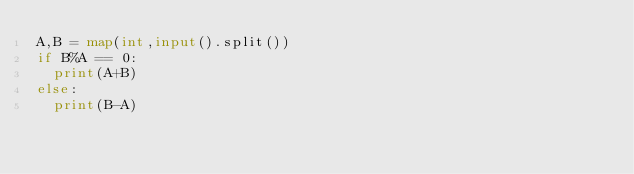Convert code to text. <code><loc_0><loc_0><loc_500><loc_500><_Python_>A,B = map(int,input().split())
if B%A == 0:
  print(A+B)
else:
  print(B-A)</code> 